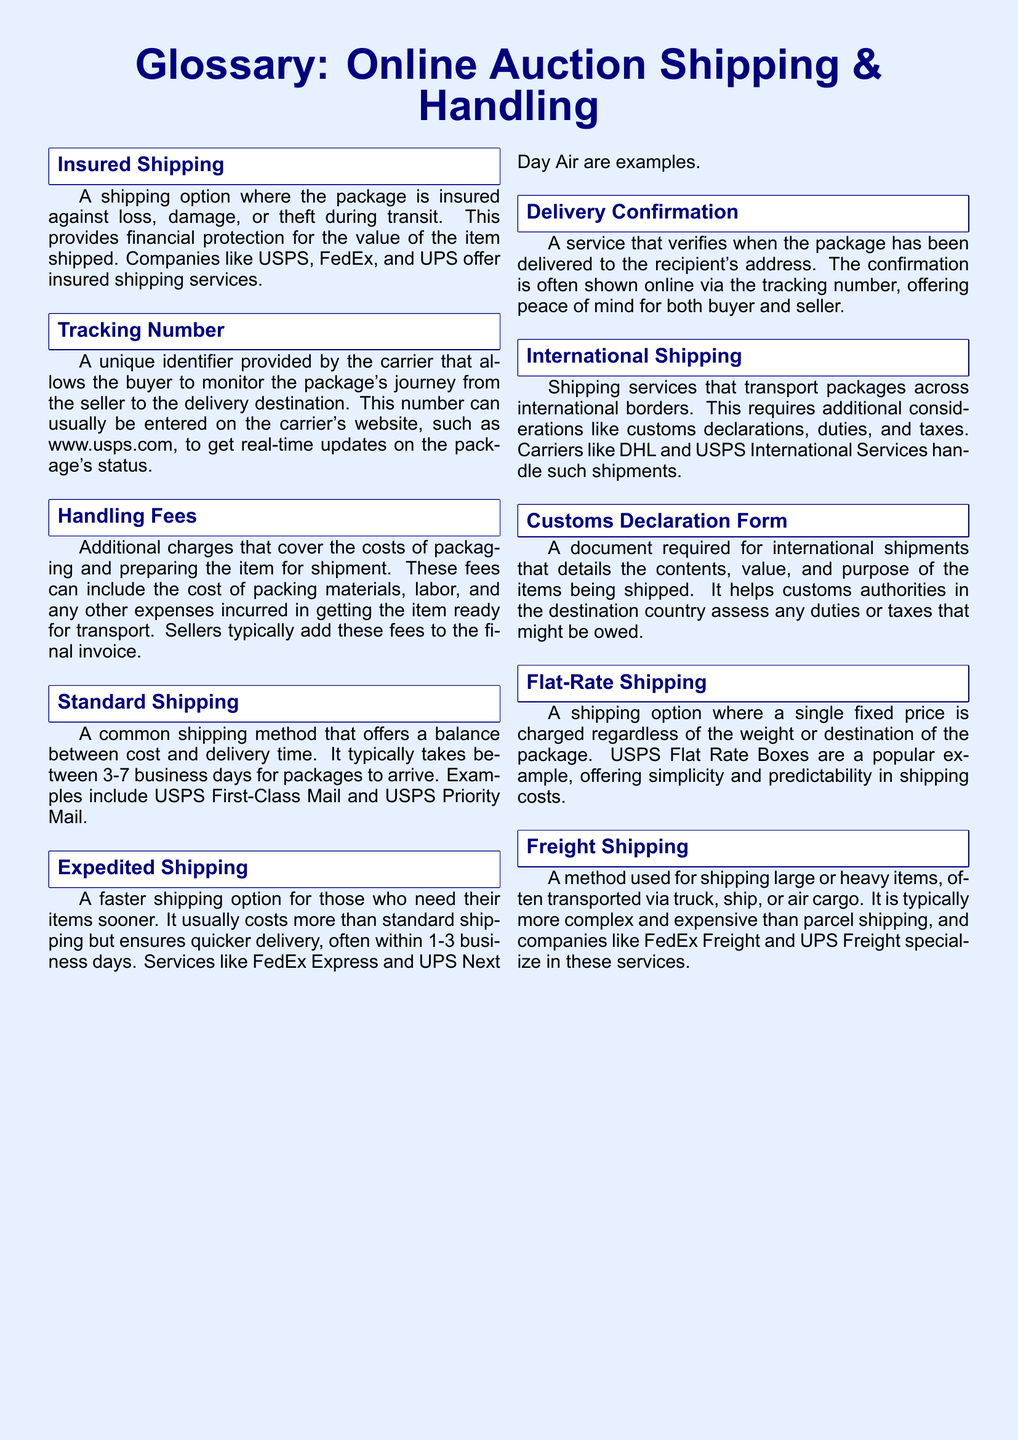What is insured shipping? Insured shipping is described as a shipping option where the package is insured against loss, damage, or theft during transit.
Answer: A shipping option where the package is insured What does the tracking number allow the buyer to do? The tracking number provides the buyer with the ability to monitor the package's journey from the seller to the delivery destination.
Answer: Monitor the package's journey What are handling fees? Handling fees are additional charges that cover the costs of packaging and preparing the item for shipment.
Answer: Additional charges for packaging and preparing What is the typical delivery time for standard shipping? The document states that standard shipping typically takes between 3-7 business days for packages to arrive.
Answer: 3-7 business days Which shipping method ensures quicker delivery? The glossary defines expedited shipping as the shipping method that ensures quicker delivery.
Answer: Expedited shipping What do flat-rate shipping options charge? Flat-rate shipping charges a single fixed price regardless of the weight or destination of the package.
Answer: A single fixed price What is required for international shipments? A customs declaration form is required for international shipments detailing contents, value, and purpose.
Answer: Customs declaration form What is freight shipping used for? Freight shipping is used for shipping large or heavy items, often transported via truck, ship, or air cargo.
Answer: Large or heavy items 